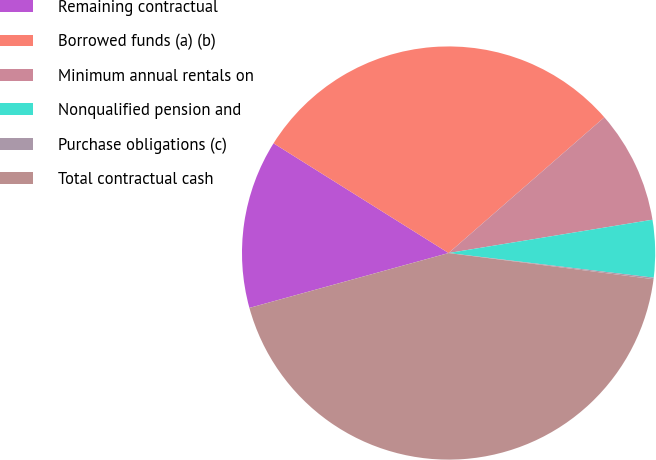<chart> <loc_0><loc_0><loc_500><loc_500><pie_chart><fcel>Remaining contractual<fcel>Borrowed funds (a) (b)<fcel>Minimum annual rentals on<fcel>Nonqualified pension and<fcel>Purchase obligations (c)<fcel>Total contractual cash<nl><fcel>13.19%<fcel>29.68%<fcel>8.83%<fcel>4.48%<fcel>0.12%<fcel>43.7%<nl></chart> 